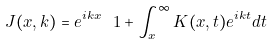Convert formula to latex. <formula><loc_0><loc_0><loc_500><loc_500>\ J ( x , k ) = e ^ { i k x } \ 1 + \int ^ { \infty } _ { x } K ( x , t ) e ^ { i k t } d t</formula> 